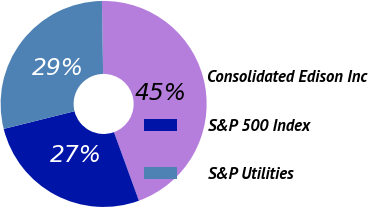Convert chart. <chart><loc_0><loc_0><loc_500><loc_500><pie_chart><fcel>Consolidated Edison Inc<fcel>S&P 500 Index<fcel>S&P Utilities<nl><fcel>44.7%<fcel>26.67%<fcel>28.63%<nl></chart> 